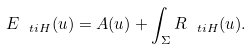<formula> <loc_0><loc_0><loc_500><loc_500>E _ { \ t i { H } } ( u ) = A ( u ) + \int _ { \Sigma } R _ { \ t i { H } } ( u ) .</formula> 